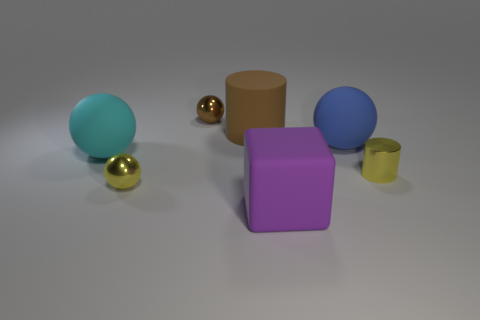Are there more yellow metal balls than big purple matte cylinders?
Ensure brevity in your answer.  Yes. There is a matte sphere right of the purple cube; does it have the same size as the large cyan object?
Keep it short and to the point. Yes. How many big matte blocks have the same color as the rubber cylinder?
Ensure brevity in your answer.  0. Is the purple matte thing the same shape as the small brown thing?
Provide a short and direct response. No. There is a yellow shiny thing that is the same shape as the small brown metallic thing; what size is it?
Your answer should be very brief. Small. Are there more brown spheres that are in front of the big blue matte object than brown metallic things that are on the right side of the small yellow cylinder?
Provide a short and direct response. No. Does the purple block have the same material as the yellow object that is on the right side of the purple rubber block?
Ensure brevity in your answer.  No. Are there any other things that are the same shape as the large purple matte object?
Your answer should be very brief. No. The matte object that is both to the right of the small brown metallic sphere and in front of the blue rubber thing is what color?
Give a very brief answer. Purple. What is the shape of the large brown matte object behind the metallic cylinder?
Keep it short and to the point. Cylinder. 